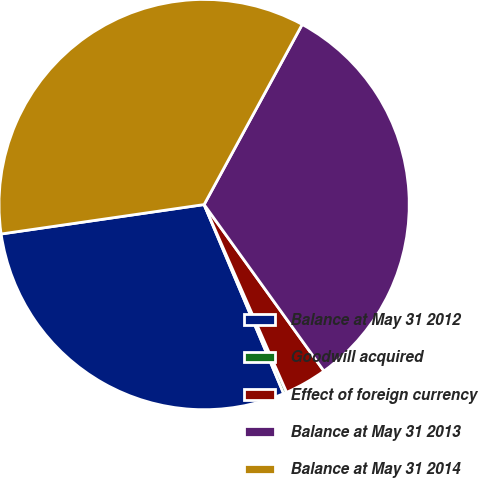Convert chart to OTSL. <chart><loc_0><loc_0><loc_500><loc_500><pie_chart><fcel>Balance at May 31 2012<fcel>Goodwill acquired<fcel>Effect of foreign currency<fcel>Balance at May 31 2013<fcel>Balance at May 31 2014<nl><fcel>29.05%<fcel>0.25%<fcel>3.34%<fcel>32.14%<fcel>35.23%<nl></chart> 